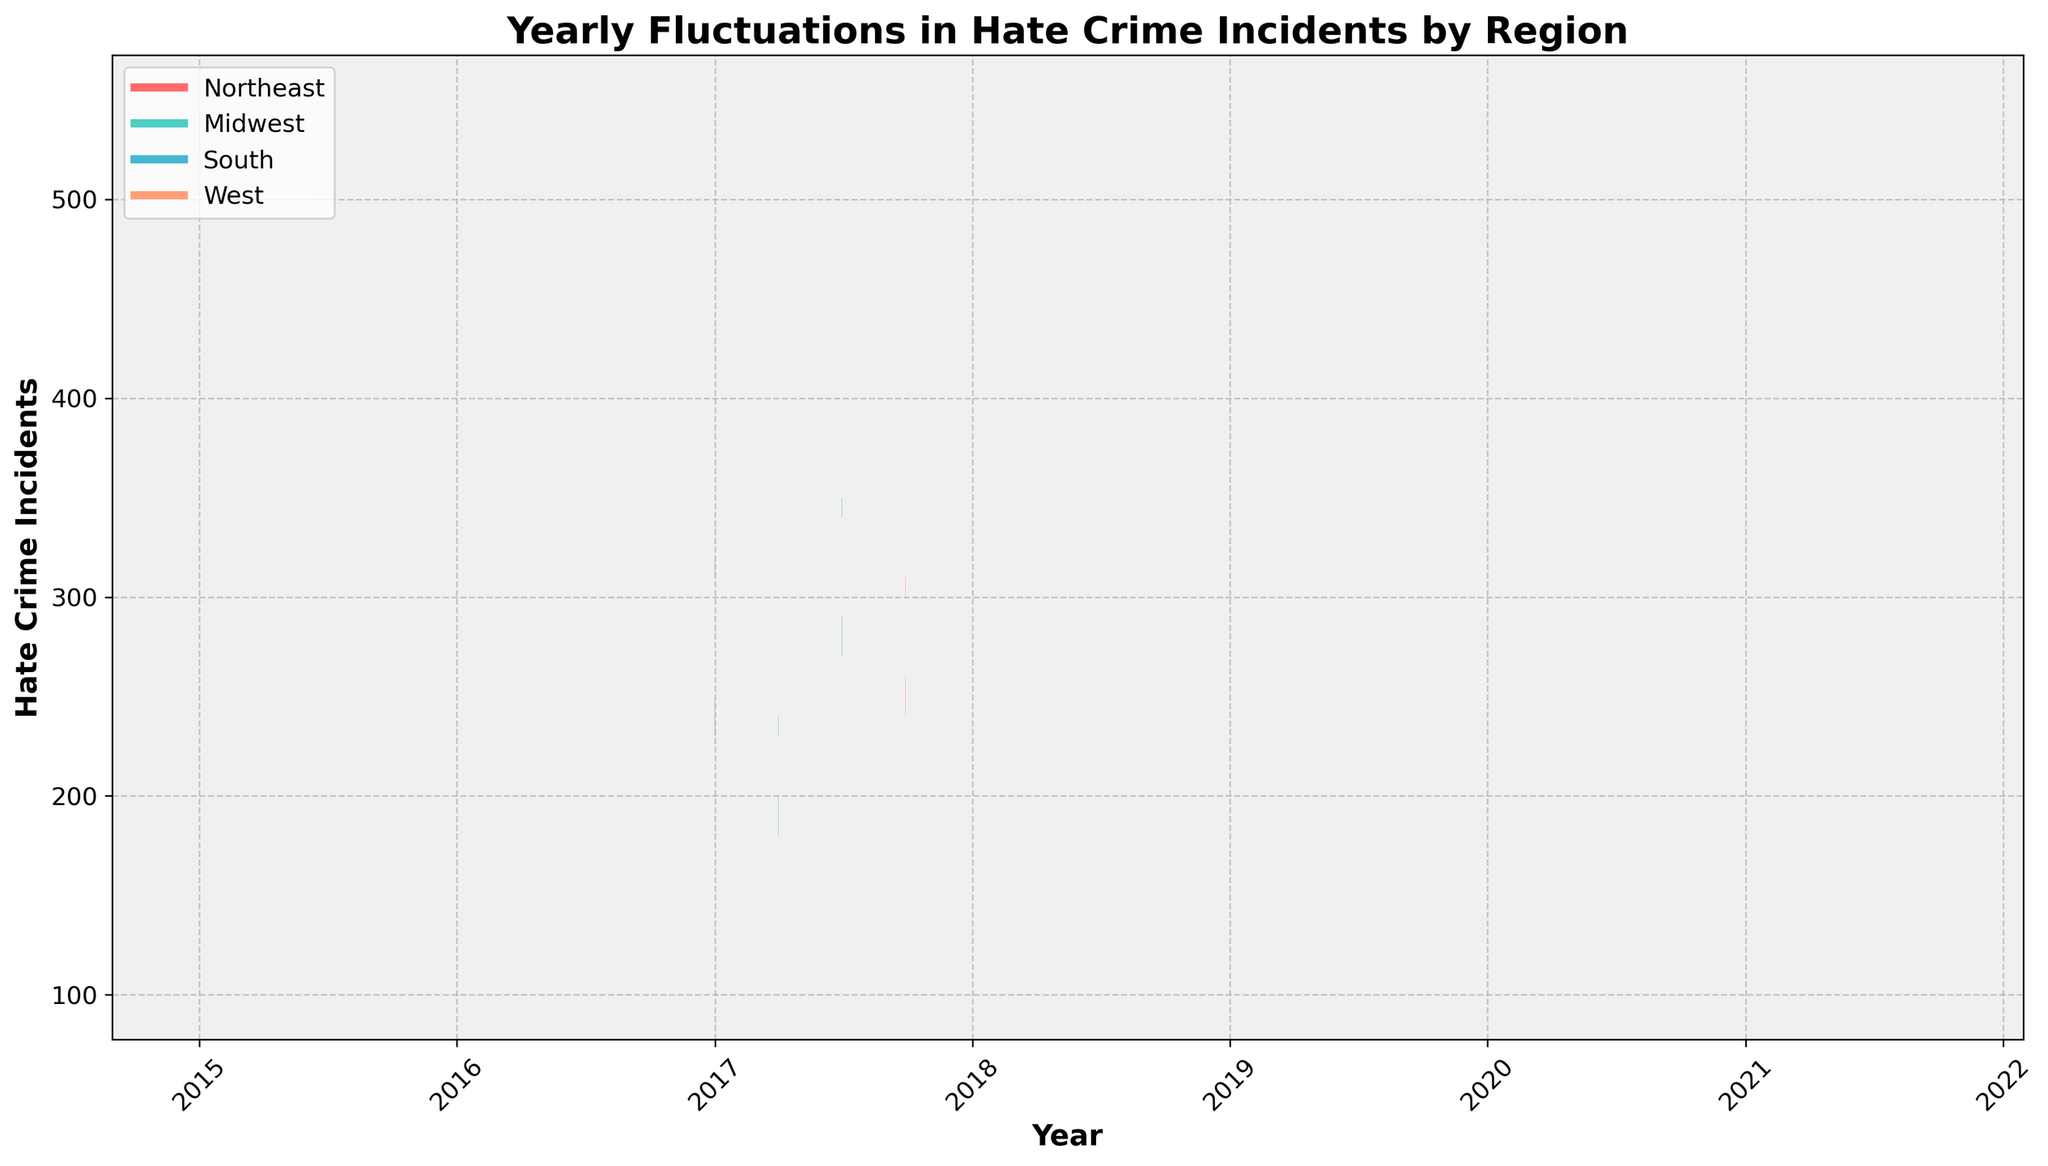What is the title of the figure? The title is displayed at the top of the figure and helps to identify the content of the plot. In this case, it summarizes the focus of the visual data representation.
Answer: Yearly Fluctuations in Hate Crime Incidents by Region How many regions are represented in the figure? By counting the distinct bars and corresponding colors in the figure, you can determine the number of regions. There are four different colors used in the bars, representing four different regions.
Answer: 4 Which year shows the highest closing value for the South region? Locate the orange bars (representing the South region) and examine the closing values (top of the bars) across different years. The year with the highest orange closing bar is the highest closing value for the South region.
Answer: 2021 In which year did the Midwest region report the highest opening value? Identify the green bars that represent the Midwest region. Look for the opening values (bottom of the central bar of the candlestick) across different years. The year with the highest opening value is the one with the greatest bottom value for the green bars.
Answer: 2020 Compare the opening and closing values for the Northeast region in 2017. Which one is greater and by how much? Identify the values for the pink bars in 2017. The bottom of the pink bar represents the opening value, and the top of the central pink bar is the closing value. Subtract the opening value from the closing value to find the difference.
Answer: Closing value is greater by 60 How does the fluctuation range (High-Low) in 2020 for the West region compare to the fluctuation range in 2019 for the same region? Examine the dark blue bars representing the West region. For 2020, the fluctuation range is 450 - 370, and for 2019, it is 400 - 320. Calculate the ranges and compare them.
Answer: The 2020 fluctuation is 10 units greater Which region had the smallest increase in the closing values from 2019 to 2020? Compare the closing values for each region across the years 2019 and 2020. Determine the increase for each by subtracting the 2019 closing value from the 2020 closing value. Identify the region with the smallest increase.
Answer: Midwest What is the pattern of fluctuations in hate crime incidents in the West region between 2015 and 2021? Observe the dark blue bars for the West region over the years from 2015 to 2021. Analyze the pattern of the heights of the highest and lowest values as well as the opening and closing values for any trends.
Answer: General upward trend with fluctuations What is the overall trend in the hate crime incidents for the Northeast region from 2015 to 2021? Observe the pink bars representing the Northeast region across the years. Analyze whether there is a consistent increase, decrease, or fluctuating trend in the values over time.
Answer: Consistent increase Which year had the lowest closing value for the Midwest region, and what was that value? Locate the green bars representing the Midwest region. Compare the closing values (top of the central green bars) across different years to find the lowest one and note the year.
Answer: 2015, 170 